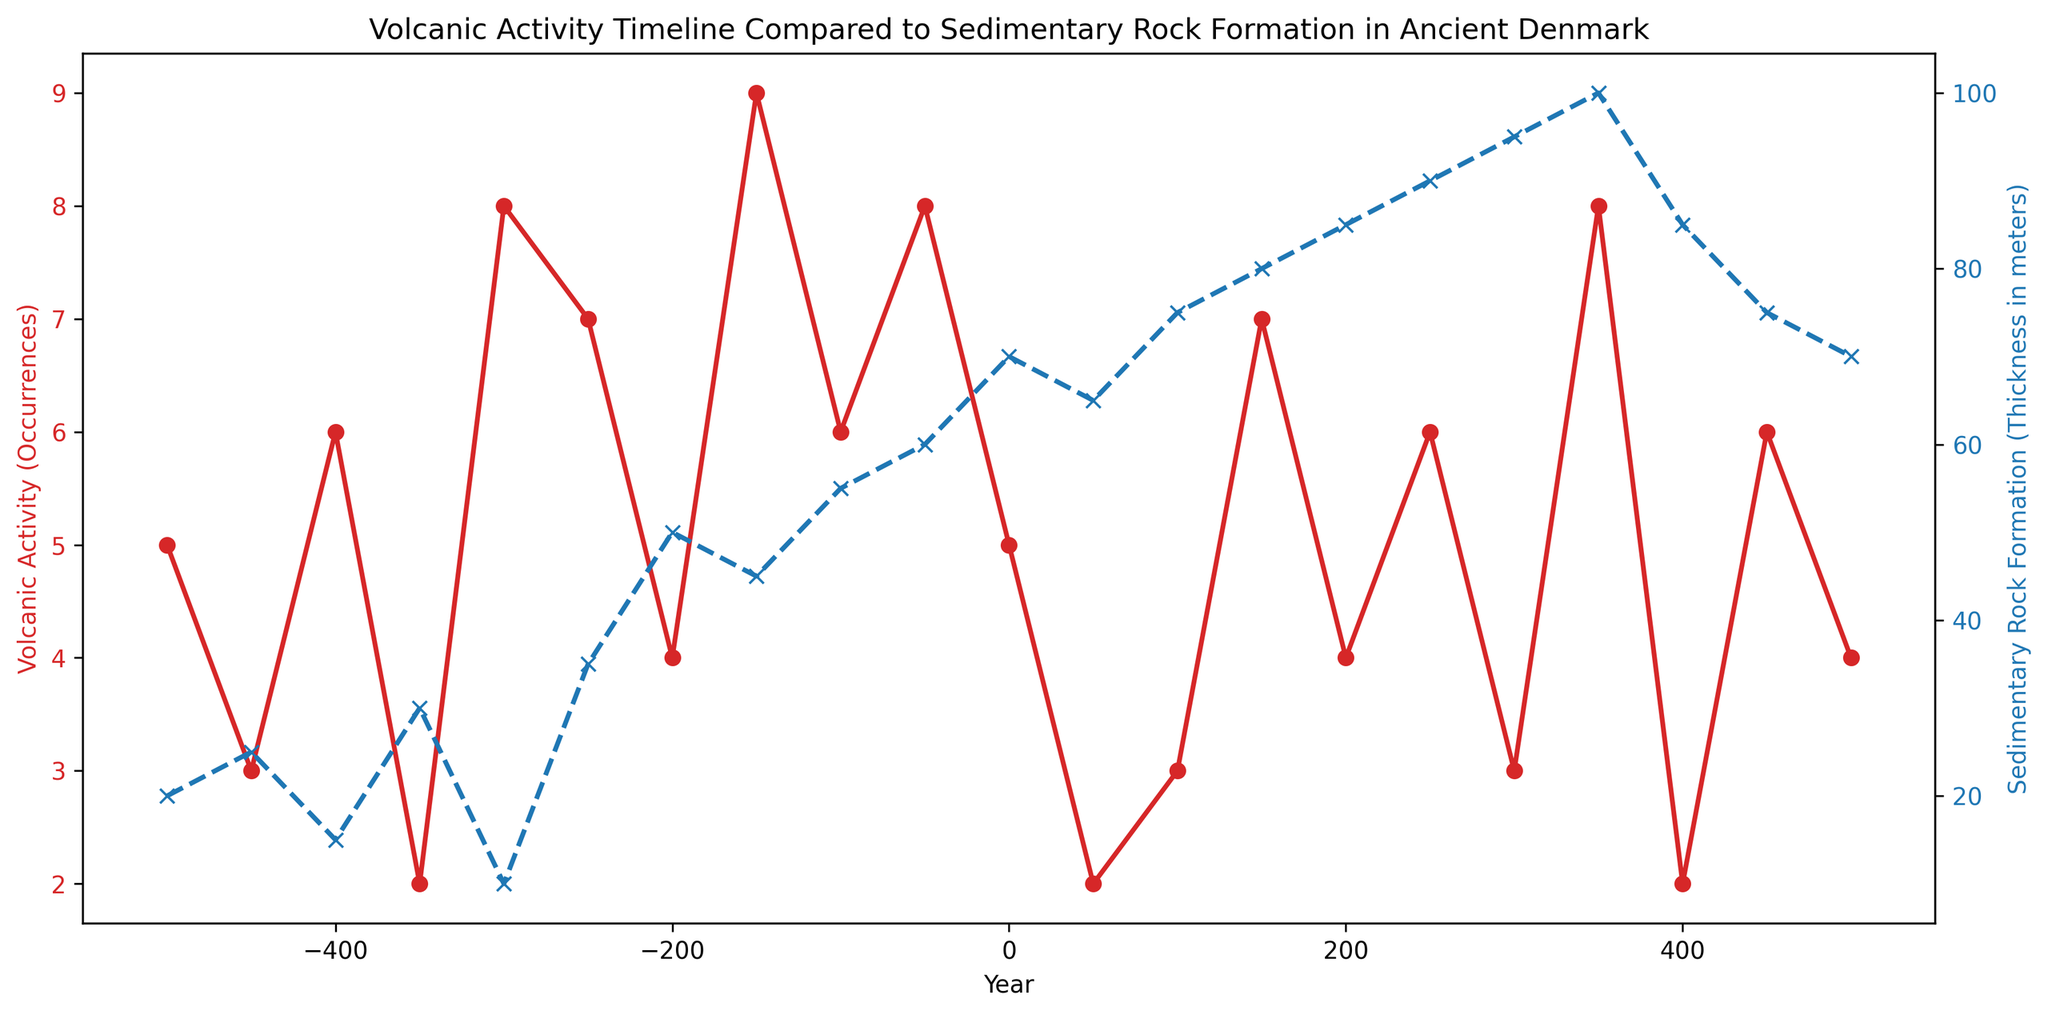Which year had the highest volcanic activity? By looking at the red line representing volcanic activity, the peak is at year -150 where it reaches 9 occurrences.
Answer: -150 At what year did the sedimentary rock formation first reach a thickness of 50 meters? Observing the blue line, the first time it reaches 50 meters is around year -200.
Answer: -200 How does the trend of volcanic activity compare to sedimentary rock formation between years -500 and 0? Volcanic activity shows fluctuating occurrences with peaks around -500, -400, -300, and varying in between, whereas sedimentary rock formation tends to increase more steadily over this period.
Answer: Fluctuating vs. Steadily increasing What is the average thickness of sedimentary rock formation from year 0 to year 500? The thickness values are 70, 65, 75, 80, 85, 90, 95, 100, 85, 75, 70 for the years from 0 to 500 respectively. Summing them (70 + 65 + 75 + 80 + 85 + 90 + 95 + 100 + 85 + 75 + 70) gives 810. Dividing by the number of years (11) gives an average thickness of approximately 73.64 meters.
Answer: 73.64 meters In which period is there the most significant increase in sedimentary rock formation thickness? Between -200 and -150, the thickness increases from 50 meters to 45 meters, showing a significant jump compared to other periods.
Answer: -200 to -150 Is there any year where both volcanic activity occurrences and sedimentary rock formation thicknesses are equal? By examining the graph, we see that the lines for volcanic activity (red) and sedimentary rock formation (blue) do not cross at any point, meaning there is no year where their values are equal.
Answer: No Which year shows the greatest decrease in volcanic activity compared to the previous year? The most significant drop in volcanic occurrences is from year -150 to -100, where it decreases from 9 to 6.
Answer: -150 to -100 How many years does sedimentary rock formation exceed 60 meters in thickness? By counting the data points on the blue line, sedimentary rock formation exceeds 60 meters from year 0 onward up to year 450, which gives 14 years.
Answer: 14 years Compare the visual appearance of the volcanic activity and sedimentary rock plots. What colors are used for each? The volcanic activity line is red, and the sedimentary rock formation line is blue.
Answer: Red and blue During which period was there a rapid increase in volcanic activity followed by a rapid decrease? From year -50 to 50, volcanic activity increased from 8 to 2, marking a rapid change.
Answer: -50 to 50 